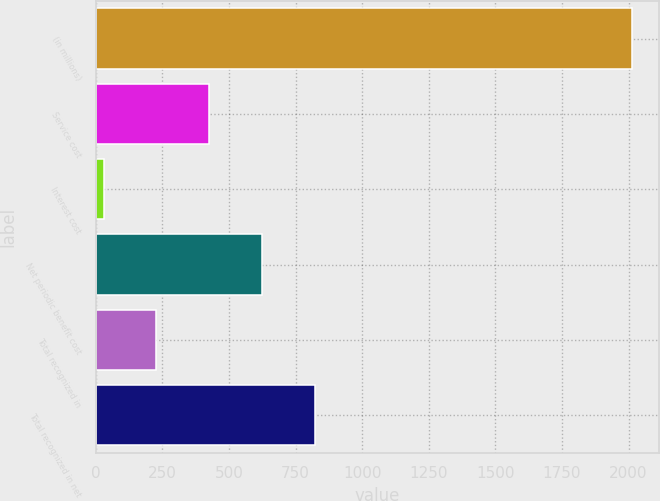Convert chart to OTSL. <chart><loc_0><loc_0><loc_500><loc_500><bar_chart><fcel>(in millions)<fcel>Service cost<fcel>Interest cost<fcel>Net periodic benefit cost<fcel>Total recognized in<fcel>Total recognized in net<nl><fcel>2014<fcel>426<fcel>29<fcel>624.5<fcel>227.5<fcel>823<nl></chart> 